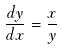<formula> <loc_0><loc_0><loc_500><loc_500>\frac { d y } { d x } = \frac { x } { y }</formula> 